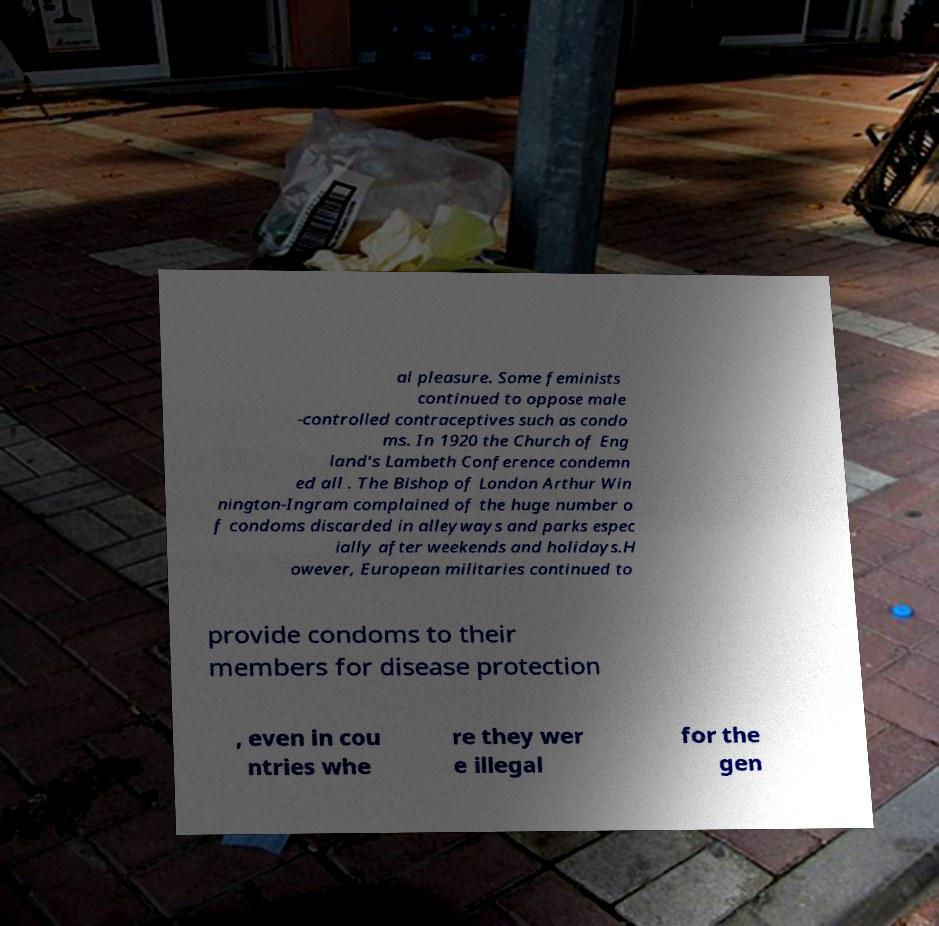For documentation purposes, I need the text within this image transcribed. Could you provide that? al pleasure. Some feminists continued to oppose male -controlled contraceptives such as condo ms. In 1920 the Church of Eng land's Lambeth Conference condemn ed all . The Bishop of London Arthur Win nington-Ingram complained of the huge number o f condoms discarded in alleyways and parks espec ially after weekends and holidays.H owever, European militaries continued to provide condoms to their members for disease protection , even in cou ntries whe re they wer e illegal for the gen 